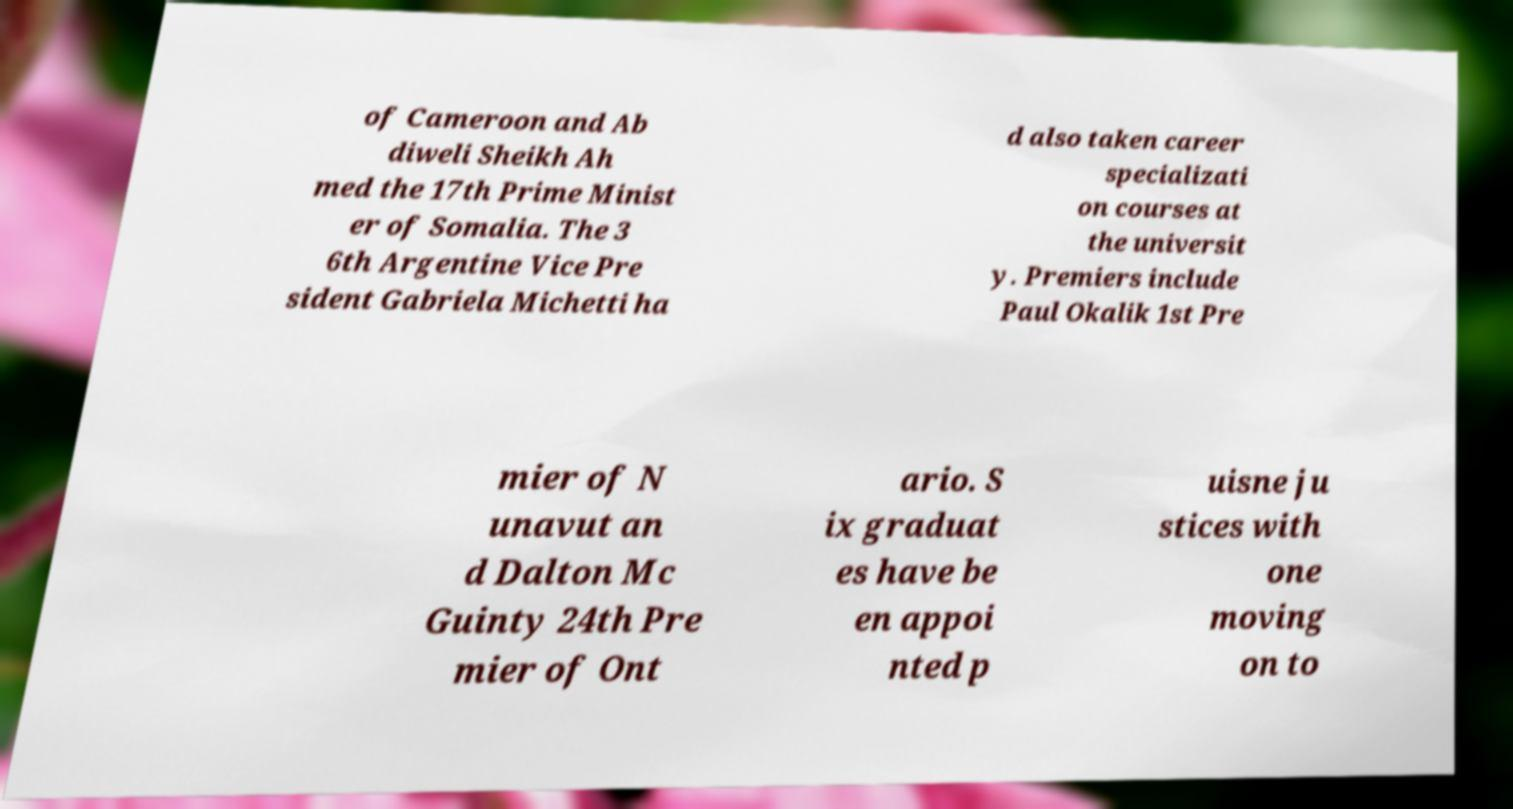What messages or text are displayed in this image? I need them in a readable, typed format. of Cameroon and Ab diweli Sheikh Ah med the 17th Prime Minist er of Somalia. The 3 6th Argentine Vice Pre sident Gabriela Michetti ha d also taken career specializati on courses at the universit y. Premiers include Paul Okalik 1st Pre mier of N unavut an d Dalton Mc Guinty 24th Pre mier of Ont ario. S ix graduat es have be en appoi nted p uisne ju stices with one moving on to 